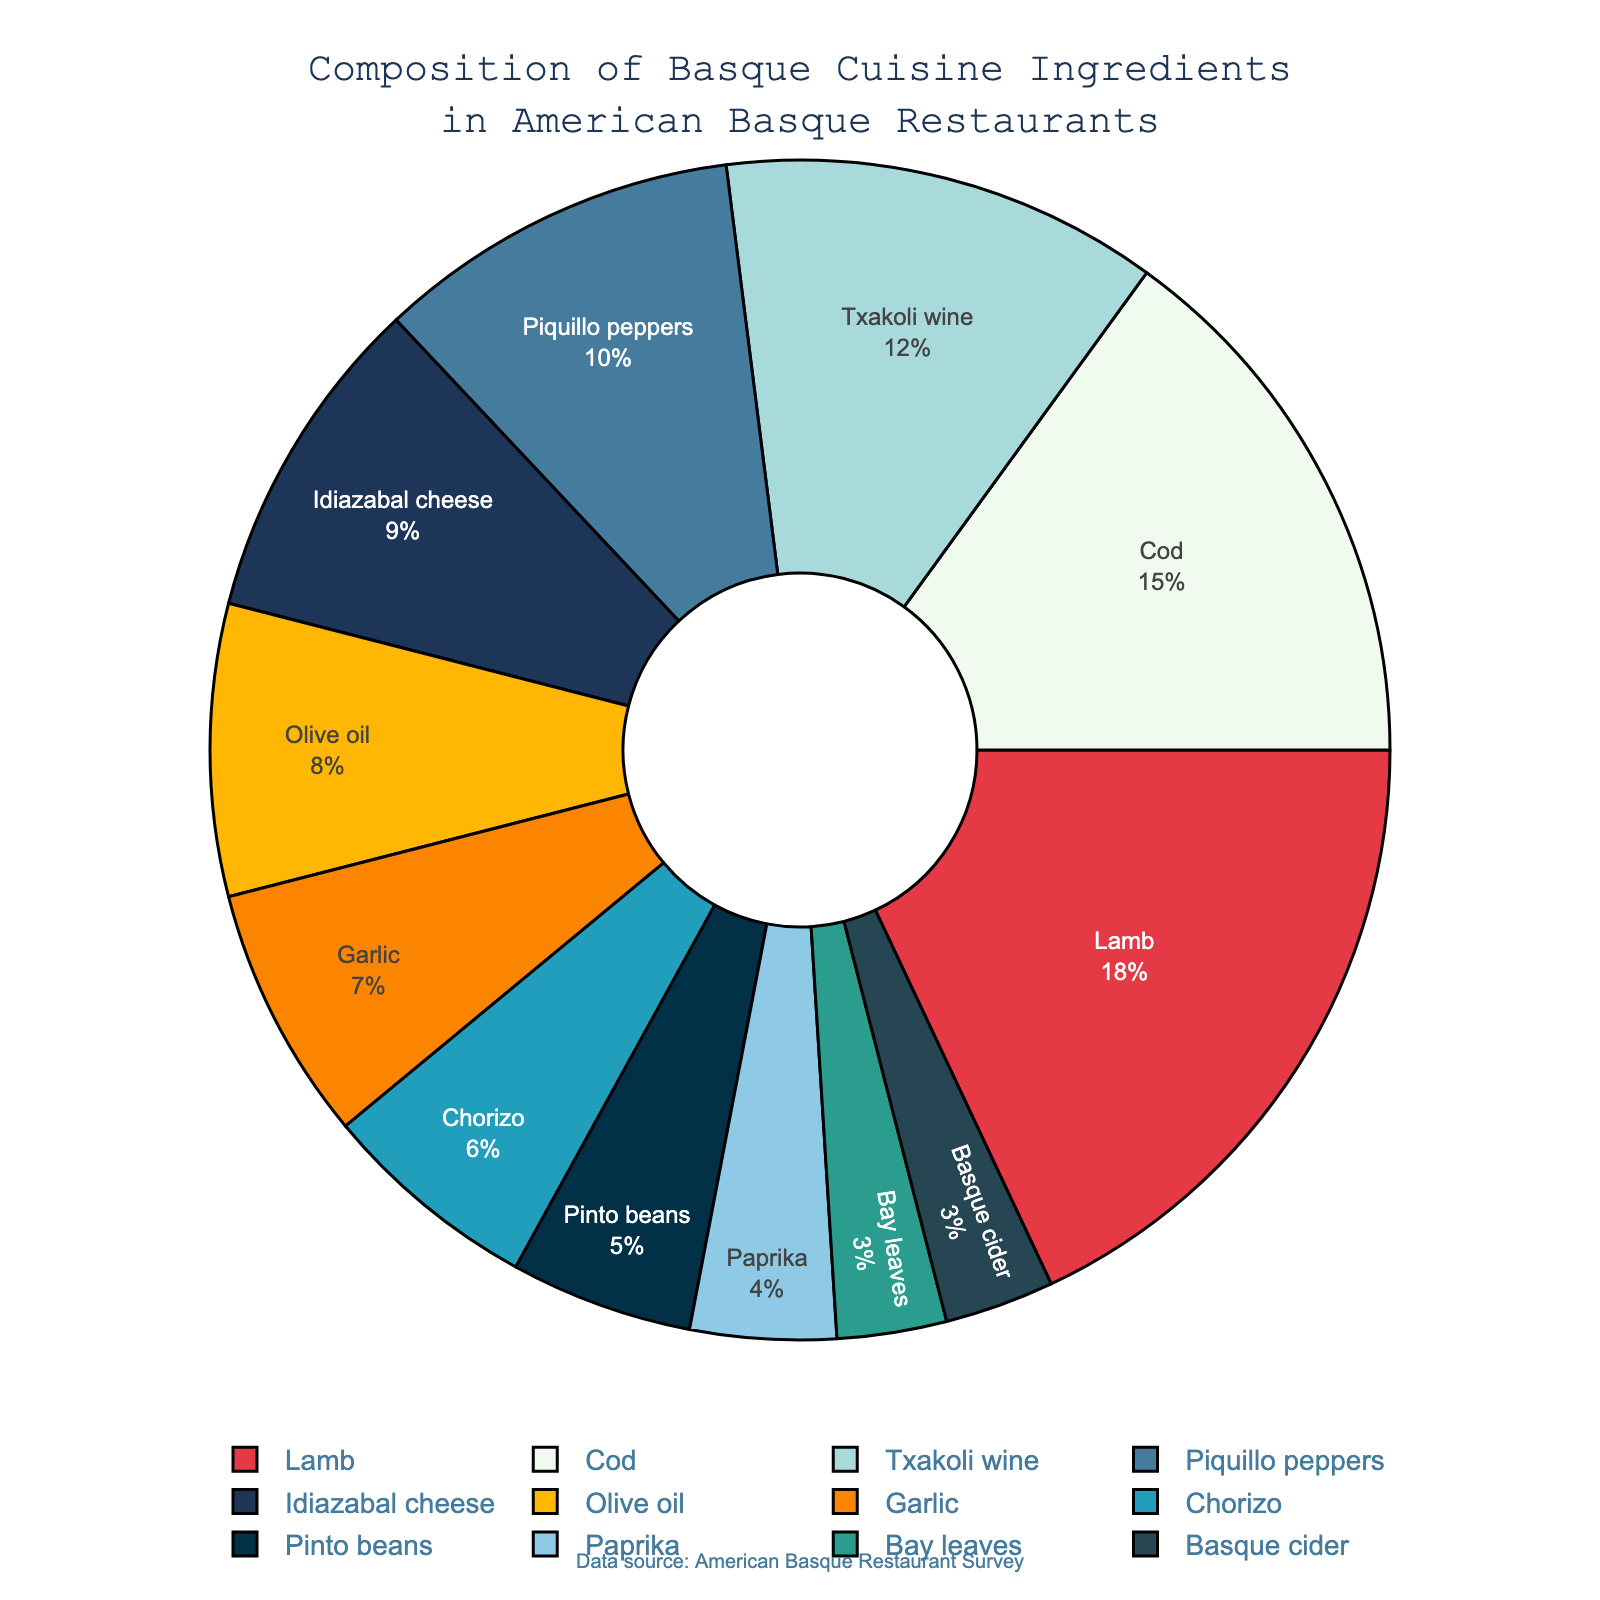What ingredient represents the highest percentage of Basque cuisine in American Basque restaurants? The pie chart shows different ingredients with their respective percentages. Lamb has the highest percentage at 18%.
Answer: Lamb Which two ingredients together make up over one-quarter of the pie chart? To find the combination, look for two ingredients whose sum of percentages exceeds 25%. Adding Lamb (18%) and Cod (15%) gives 33%, which is over one-quarter (25%).
Answer: Lamb and Cod How much more prevalent is Lamb compared to Idiazabal cheese? Find the percentage for Lamb and Idiazabal cheese, then subtract the latter from the former. Lamb is 18% and Idiazabal cheese is 9%, so 18% - 9% = 9%.
Answer: 9% What proportion of the composition does the combination of Piquillo peppers and Olive oil represent? Sum the percentages of Piquillo peppers and Olive oil. Piquillo peppers are 10% and Olive oil is 8%, so 10% + 8% = 18%.
Answer: 18% Which ingredient is represented with a greenish-blue color on the pie chart? The pie chart uses specific colors for each slice. By observing the visual attribute, Pinto beans which make up 5% are represented with the greenish-blue color.
Answer: Pinto beans What percentage of the pie chart is dedicated to ingredients other than Lamb and Cod? Subtract the combined percentage of Lamb and Cod from 100%. Lamb is 18% and Cod is 15%, so 100% - (18% + 15%) = 67%.
Answer: 67% Are there more ingredients contributing less than 7% or more than 7% of the composition? Count the ingredients that contribute less than 7% and those that contribute more. Ingredients less than 7%: Chorizo, Pinto beans, Paprika, Bay leaves, Basque cider (5). Ingredients more than 7%: Lamb, Cod, Txakoli wine, Piquillo peppers, Idiazabal cheese, Olive oil, Garlic (7).
Answer: More than 7% Which ingredient contributes equally with another to the composition of Basque cuisine? Identify two ingredients with the same percentage. Both Bay leaves and Basque cider contribute 3% each.
Answer: Bay leaves and Basque cider What percentage do the least prevalent ingredients combined make up? Identify the least prevalent ingredients and sum their percentages. The least prevalent are Bay leaves and Basque cider, each 3%. So, 3% + 3% = 6%.
Answer: 6% 